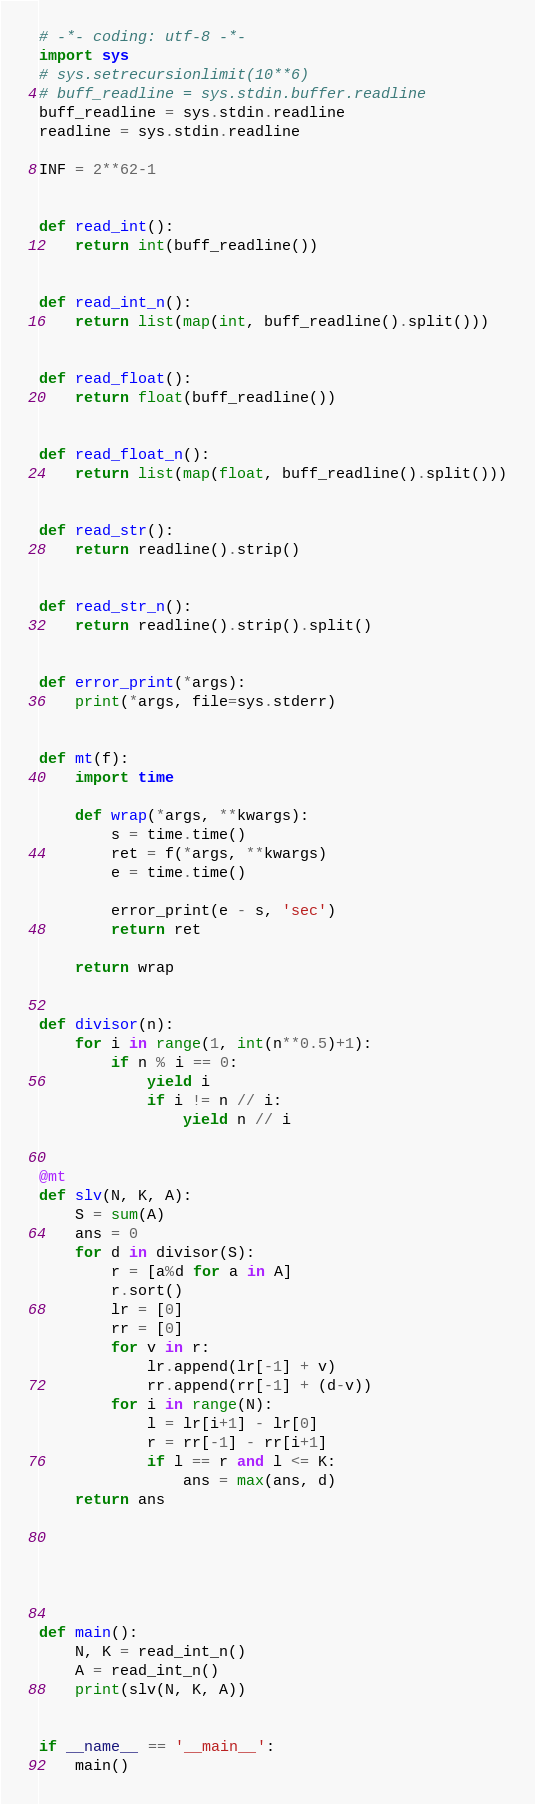<code> <loc_0><loc_0><loc_500><loc_500><_Python_># -*- coding: utf-8 -*-
import sys
# sys.setrecursionlimit(10**6)
# buff_readline = sys.stdin.buffer.readline
buff_readline = sys.stdin.readline
readline = sys.stdin.readline

INF = 2**62-1


def read_int():
    return int(buff_readline())


def read_int_n():
    return list(map(int, buff_readline().split()))


def read_float():
    return float(buff_readline())


def read_float_n():
    return list(map(float, buff_readline().split()))


def read_str():
    return readline().strip()


def read_str_n():
    return readline().strip().split()


def error_print(*args):
    print(*args, file=sys.stderr)


def mt(f):
    import time

    def wrap(*args, **kwargs):
        s = time.time()
        ret = f(*args, **kwargs)
        e = time.time()

        error_print(e - s, 'sec')
        return ret

    return wrap


def divisor(n):
    for i in range(1, int(n**0.5)+1):
        if n % i == 0:
            yield i
            if i != n // i:
                yield n // i


@mt
def slv(N, K, A):
    S = sum(A)
    ans = 0
    for d in divisor(S):
        r = [a%d for a in A]
        r.sort()
        lr = [0]
        rr = [0]
        for v in r:
            lr.append(lr[-1] + v)
            rr.append(rr[-1] + (d-v))
        for i in range(N):
            l = lr[i+1] - lr[0]
            r = rr[-1] - rr[i+1]
            if l == r and l <= K:
                ans = max(ans, d)
    return ans






def main():
    N, K = read_int_n()
    A = read_int_n()
    print(slv(N, K, A))


if __name__ == '__main__':
    main()
</code> 